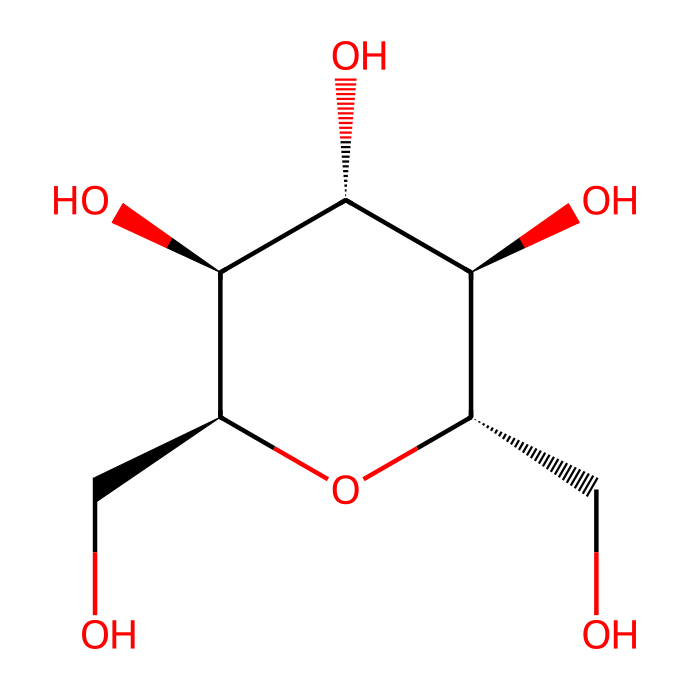How many carbon atoms are in this chemical? By analyzing the SMILES representation, we see multiple carbon symbols (C) present in the structure. Each carbon atom contributes to the backbone of the molecule. Counting these, we find a total of six carbon atoms.
Answer: six What type of carbohydrate does this structure represent? The structure contains multiple hydroxyl (–OH) groups and a ring form, characteristic of polysaccharides. Given the arrangement of the atoms, the carbohydrate is likely a type of sugar, specifically a glucan or a derivative of glucose, indicating it's a complex carbohydrate.
Answer: polysaccharide How many hydroxyl groups are present in this chemical? Each hydroxyl (–OH) group can be identified in the structure by looking for oxygen atoms bonded to hydrogen atoms. In this molecule, we count four distinct –OH groups attached to different carbon atoms.
Answer: four What does the term "complex carbohydrate" indicate about this molecule? "Complex carbohydrate" refers to polysaccharides, which consist of long chains of sugar molecules. This structure, characterized by its multiple sugar units and branching, indicates it belongs to the complex carbohydrate category, which is known for being a source of sustained energy.
Answer: long chains of sugar molecules Are there any functional groups present, and if so, what are they? In examining the structure, we identify the presence of hydroxyl (–OH) groups as the primary functional groups. These groups are crucial for the solubility and reactivity of carbohydrates, impacting their biological function and interaction with other molecules.
Answer: hydroxyl groups 